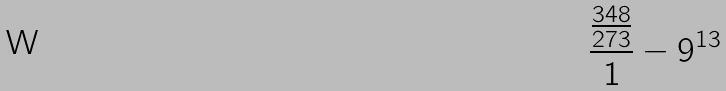Convert formula to latex. <formula><loc_0><loc_0><loc_500><loc_500>\frac { \frac { 3 4 8 } { 2 7 3 } } { 1 } - 9 ^ { 1 3 }</formula> 